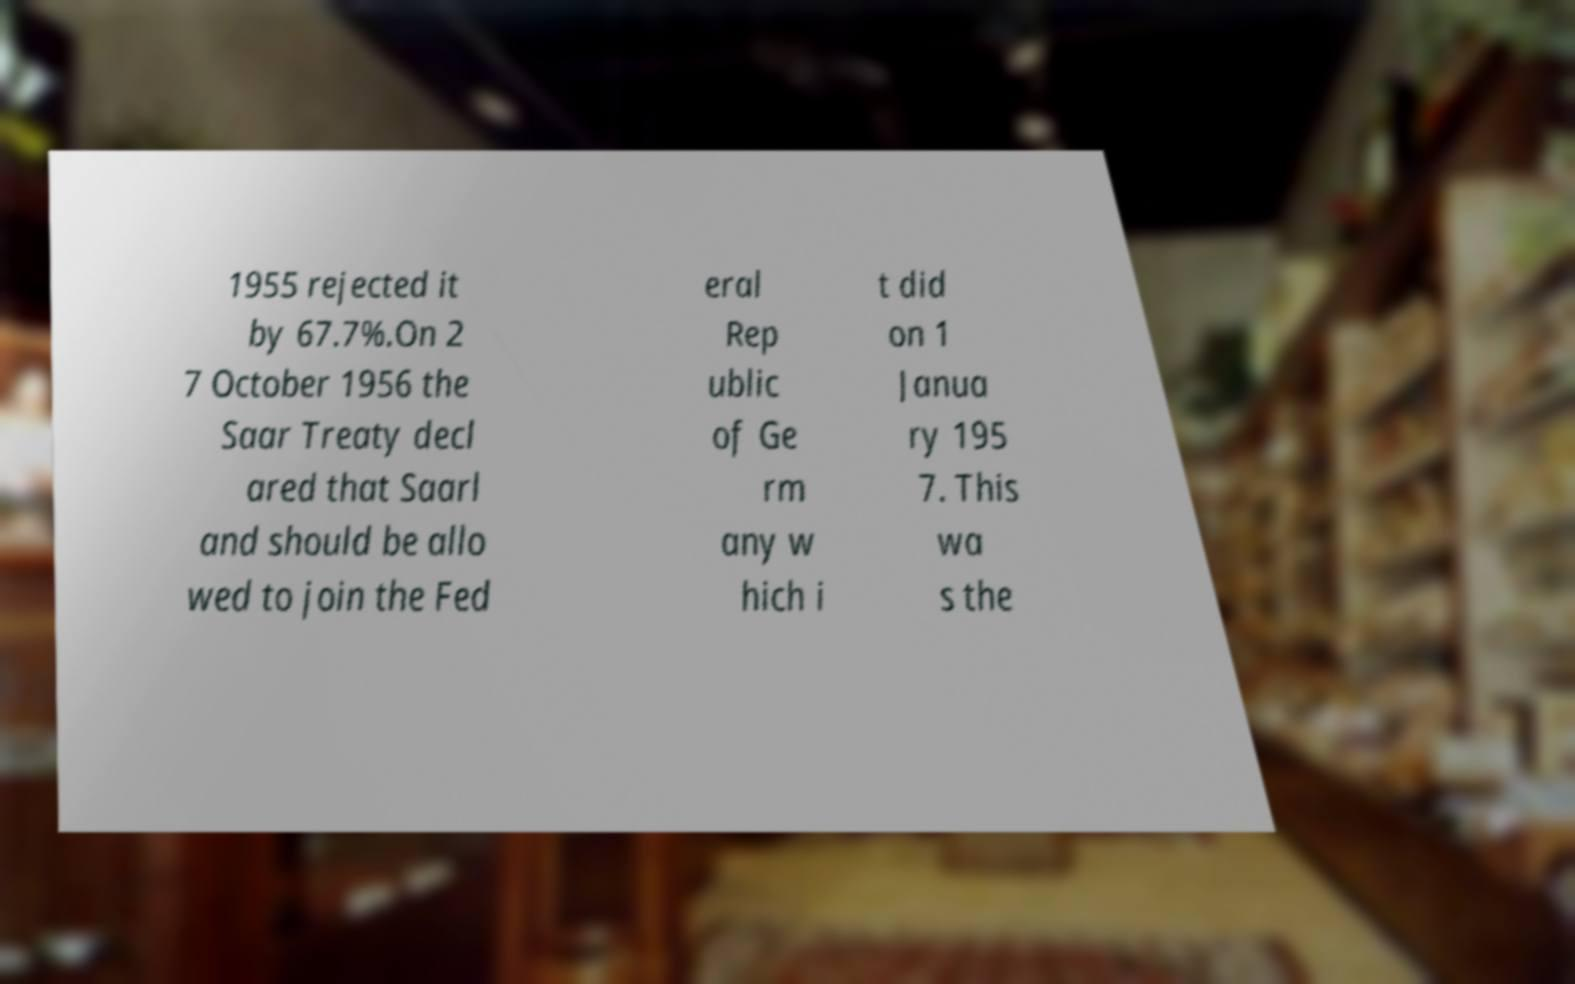What messages or text are displayed in this image? I need them in a readable, typed format. 1955 rejected it by 67.7%.On 2 7 October 1956 the Saar Treaty decl ared that Saarl and should be allo wed to join the Fed eral Rep ublic of Ge rm any w hich i t did on 1 Janua ry 195 7. This wa s the 